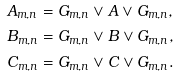Convert formula to latex. <formula><loc_0><loc_0><loc_500><loc_500>A _ { m , n } & = G _ { m , n } \vee A \vee G _ { m , n } , \\ B _ { m , n } & = G _ { m , n } \vee B \vee G _ { m , n } , \\ C _ { m , n } & = G _ { m , n } \vee C \vee G _ { m , n } .</formula> 